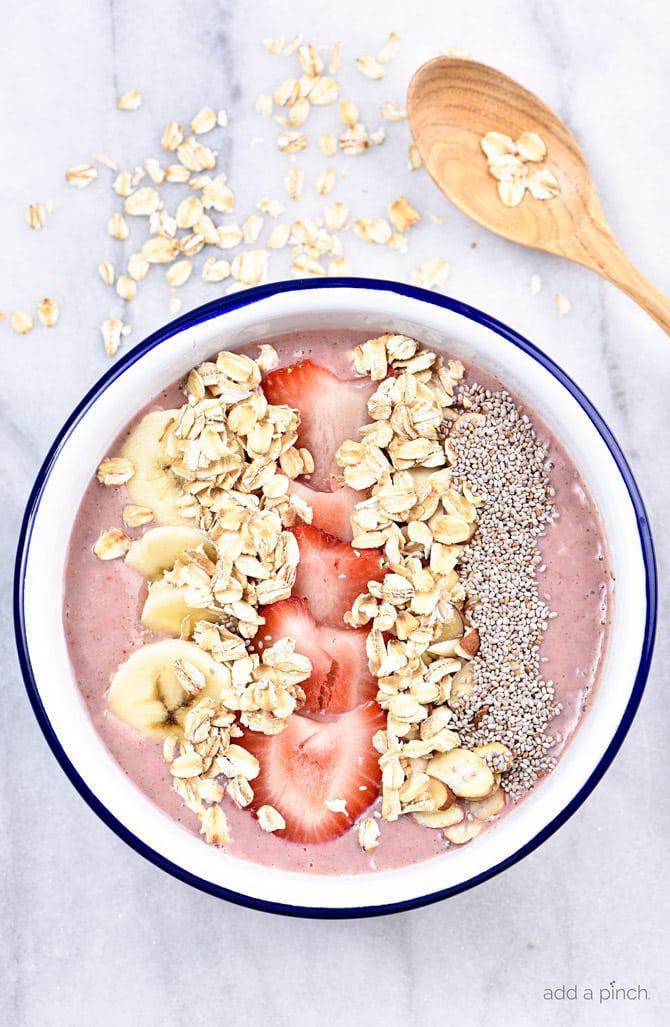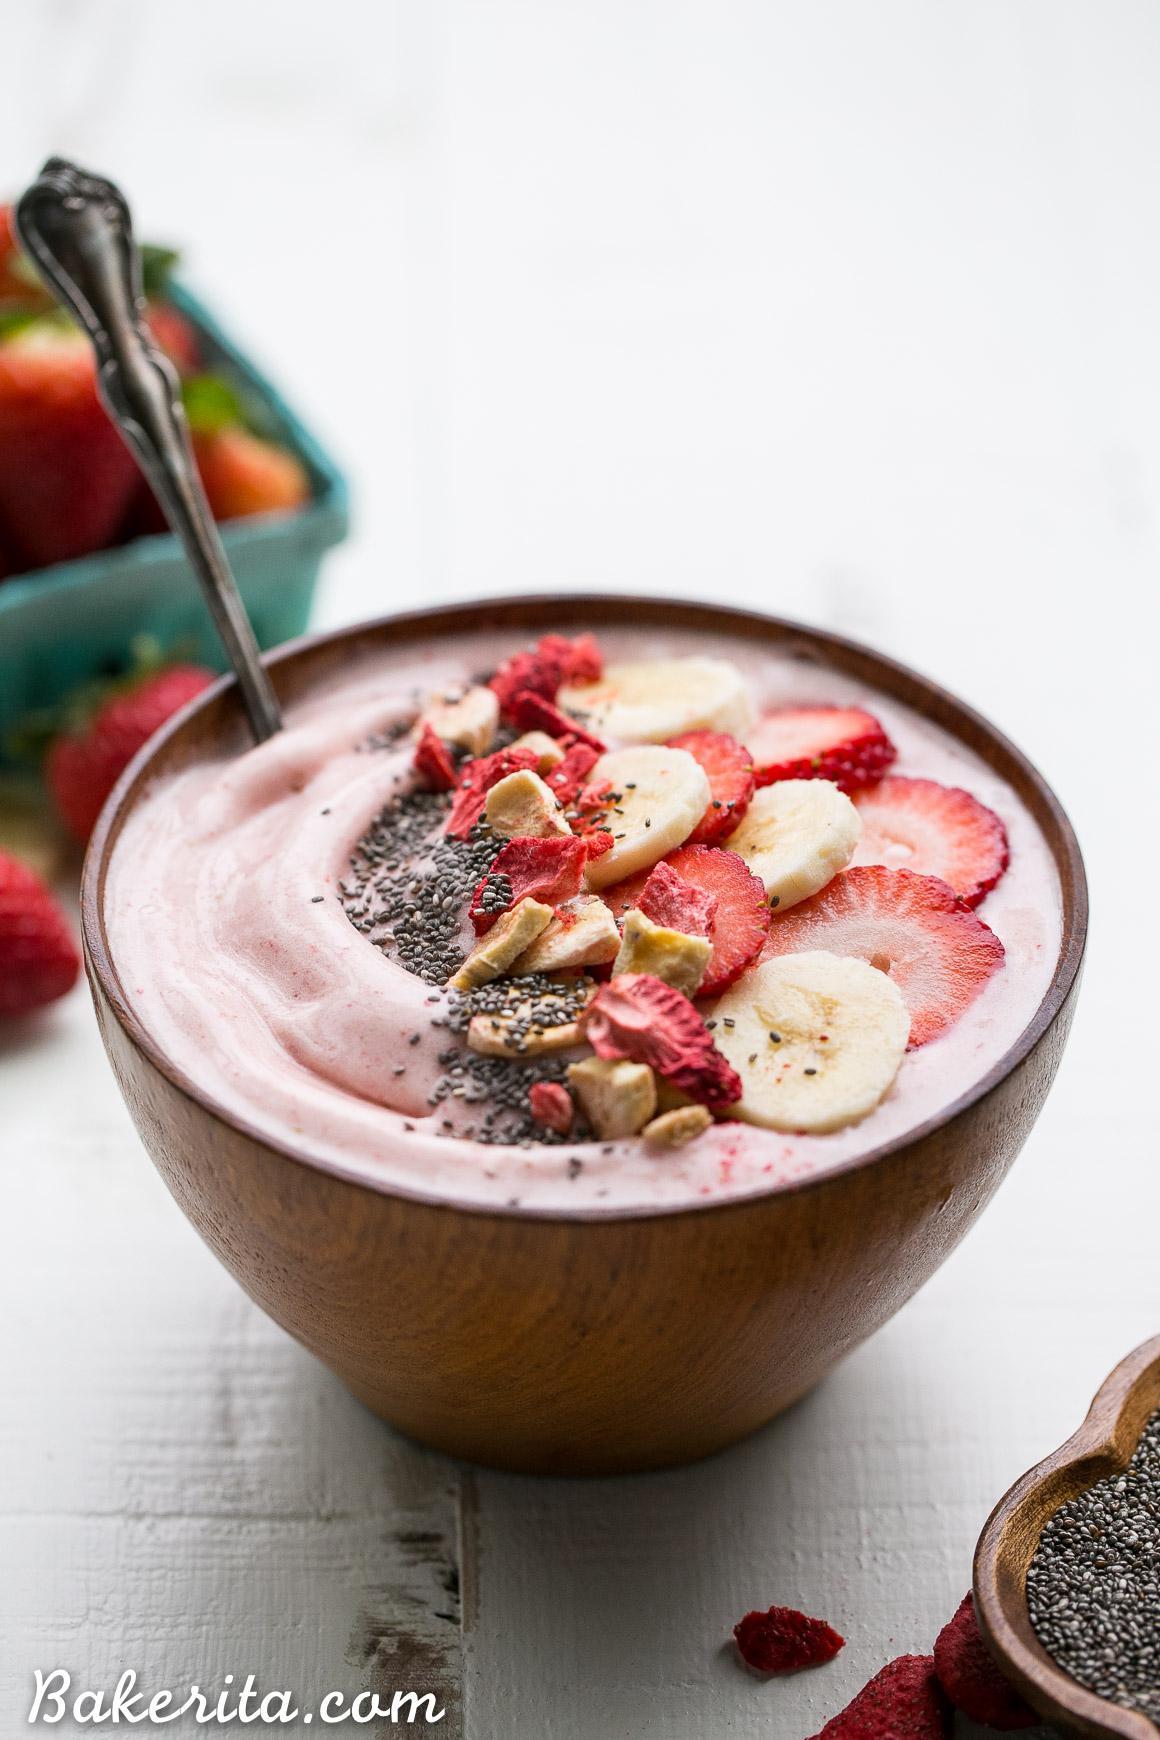The first image is the image on the left, the second image is the image on the right. Analyze the images presented: Is the assertion "The combined images include a white bowl topped with blueberries and other ingredients, a square white container of fruit behind a white bowl, and a blue-striped white cloth next to a bowl." valid? Answer yes or no. No. The first image is the image on the left, the second image is the image on the right. Evaluate the accuracy of this statement regarding the images: "There are at least two white bowls.". Is it true? Answer yes or no. No. 